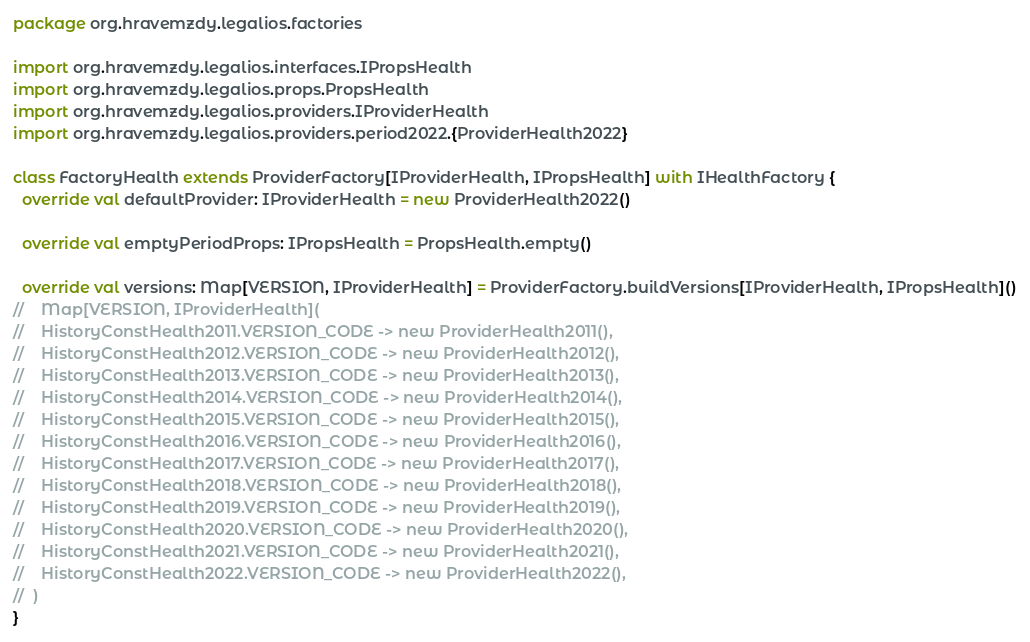Convert code to text. <code><loc_0><loc_0><loc_500><loc_500><_Scala_>package org.hravemzdy.legalios.factories

import org.hravemzdy.legalios.interfaces.IPropsHealth
import org.hravemzdy.legalios.props.PropsHealth
import org.hravemzdy.legalios.providers.IProviderHealth
import org.hravemzdy.legalios.providers.period2022.{ProviderHealth2022}

class FactoryHealth extends ProviderFactory[IProviderHealth, IPropsHealth] with IHealthFactory {
  override val defaultProvider: IProviderHealth = new ProviderHealth2022()

  override val emptyPeriodProps: IPropsHealth = PropsHealth.empty()

  override val versions: Map[VERSION, IProviderHealth] = ProviderFactory.buildVersions[IProviderHealth, IPropsHealth]()
//    Map[VERSION, IProviderHealth](
//    HistoryConstHealth2011.VERSION_CODE -> new ProviderHealth2011(),
//    HistoryConstHealth2012.VERSION_CODE -> new ProviderHealth2012(),
//    HistoryConstHealth2013.VERSION_CODE -> new ProviderHealth2013(),
//    HistoryConstHealth2014.VERSION_CODE -> new ProviderHealth2014(),
//    HistoryConstHealth2015.VERSION_CODE -> new ProviderHealth2015(),
//    HistoryConstHealth2016.VERSION_CODE -> new ProviderHealth2016(),
//    HistoryConstHealth2017.VERSION_CODE -> new ProviderHealth2017(),
//    HistoryConstHealth2018.VERSION_CODE -> new ProviderHealth2018(),
//    HistoryConstHealth2019.VERSION_CODE -> new ProviderHealth2019(),
//    HistoryConstHealth2020.VERSION_CODE -> new ProviderHealth2020(),
//    HistoryConstHealth2021.VERSION_CODE -> new ProviderHealth2021(),
//    HistoryConstHealth2022.VERSION_CODE -> new ProviderHealth2022(),
//  )
}
</code> 